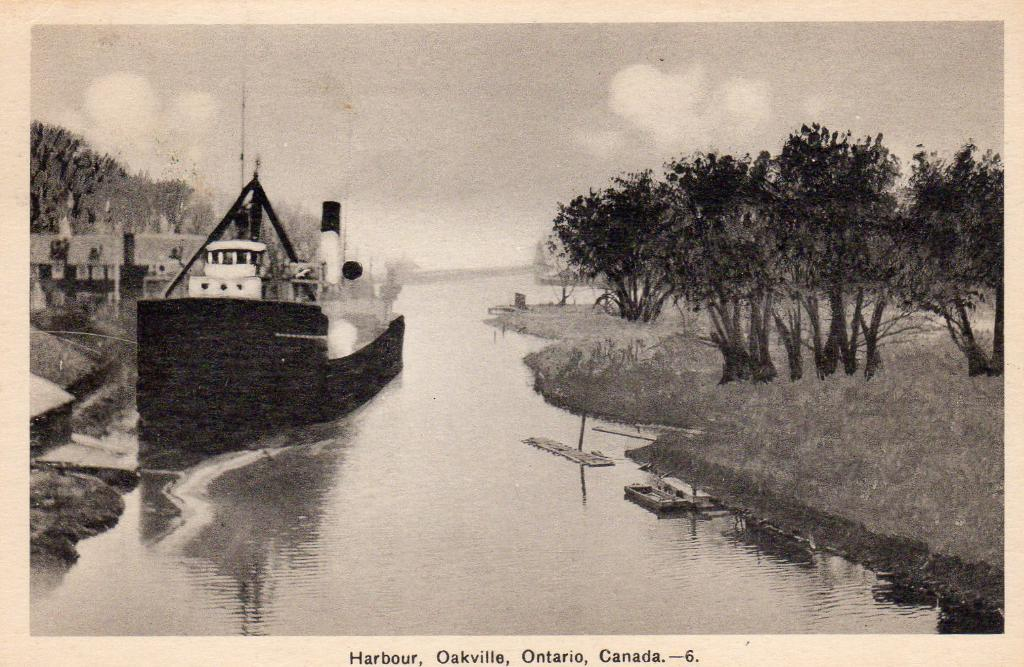<image>
Write a terse but informative summary of the picture. a photo that has the word Harbour at the bottom 